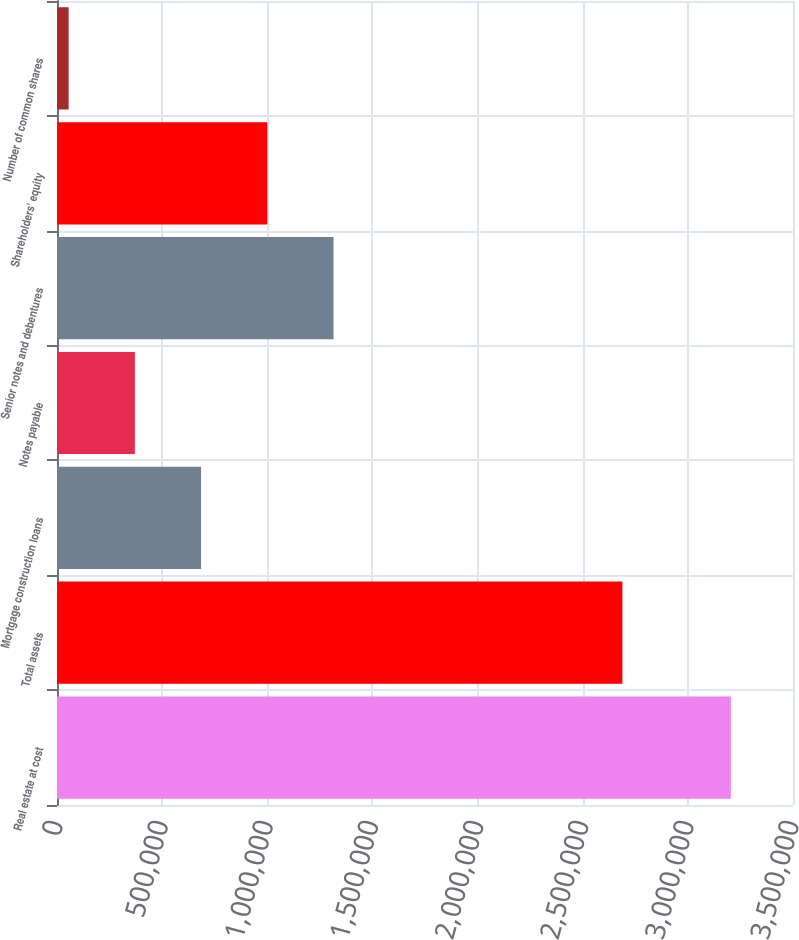<chart> <loc_0><loc_0><loc_500><loc_500><bar_chart><fcel>Real estate at cost<fcel>Total assets<fcel>Mortgage construction loans<fcel>Notes payable<fcel>Senior notes and debentures<fcel>Shareholders' equity<fcel>Number of common shares<nl><fcel>3.20426e+06<fcel>2.68861e+06<fcel>685108<fcel>370215<fcel>1.3149e+06<fcel>1e+06<fcel>55321<nl></chart> 